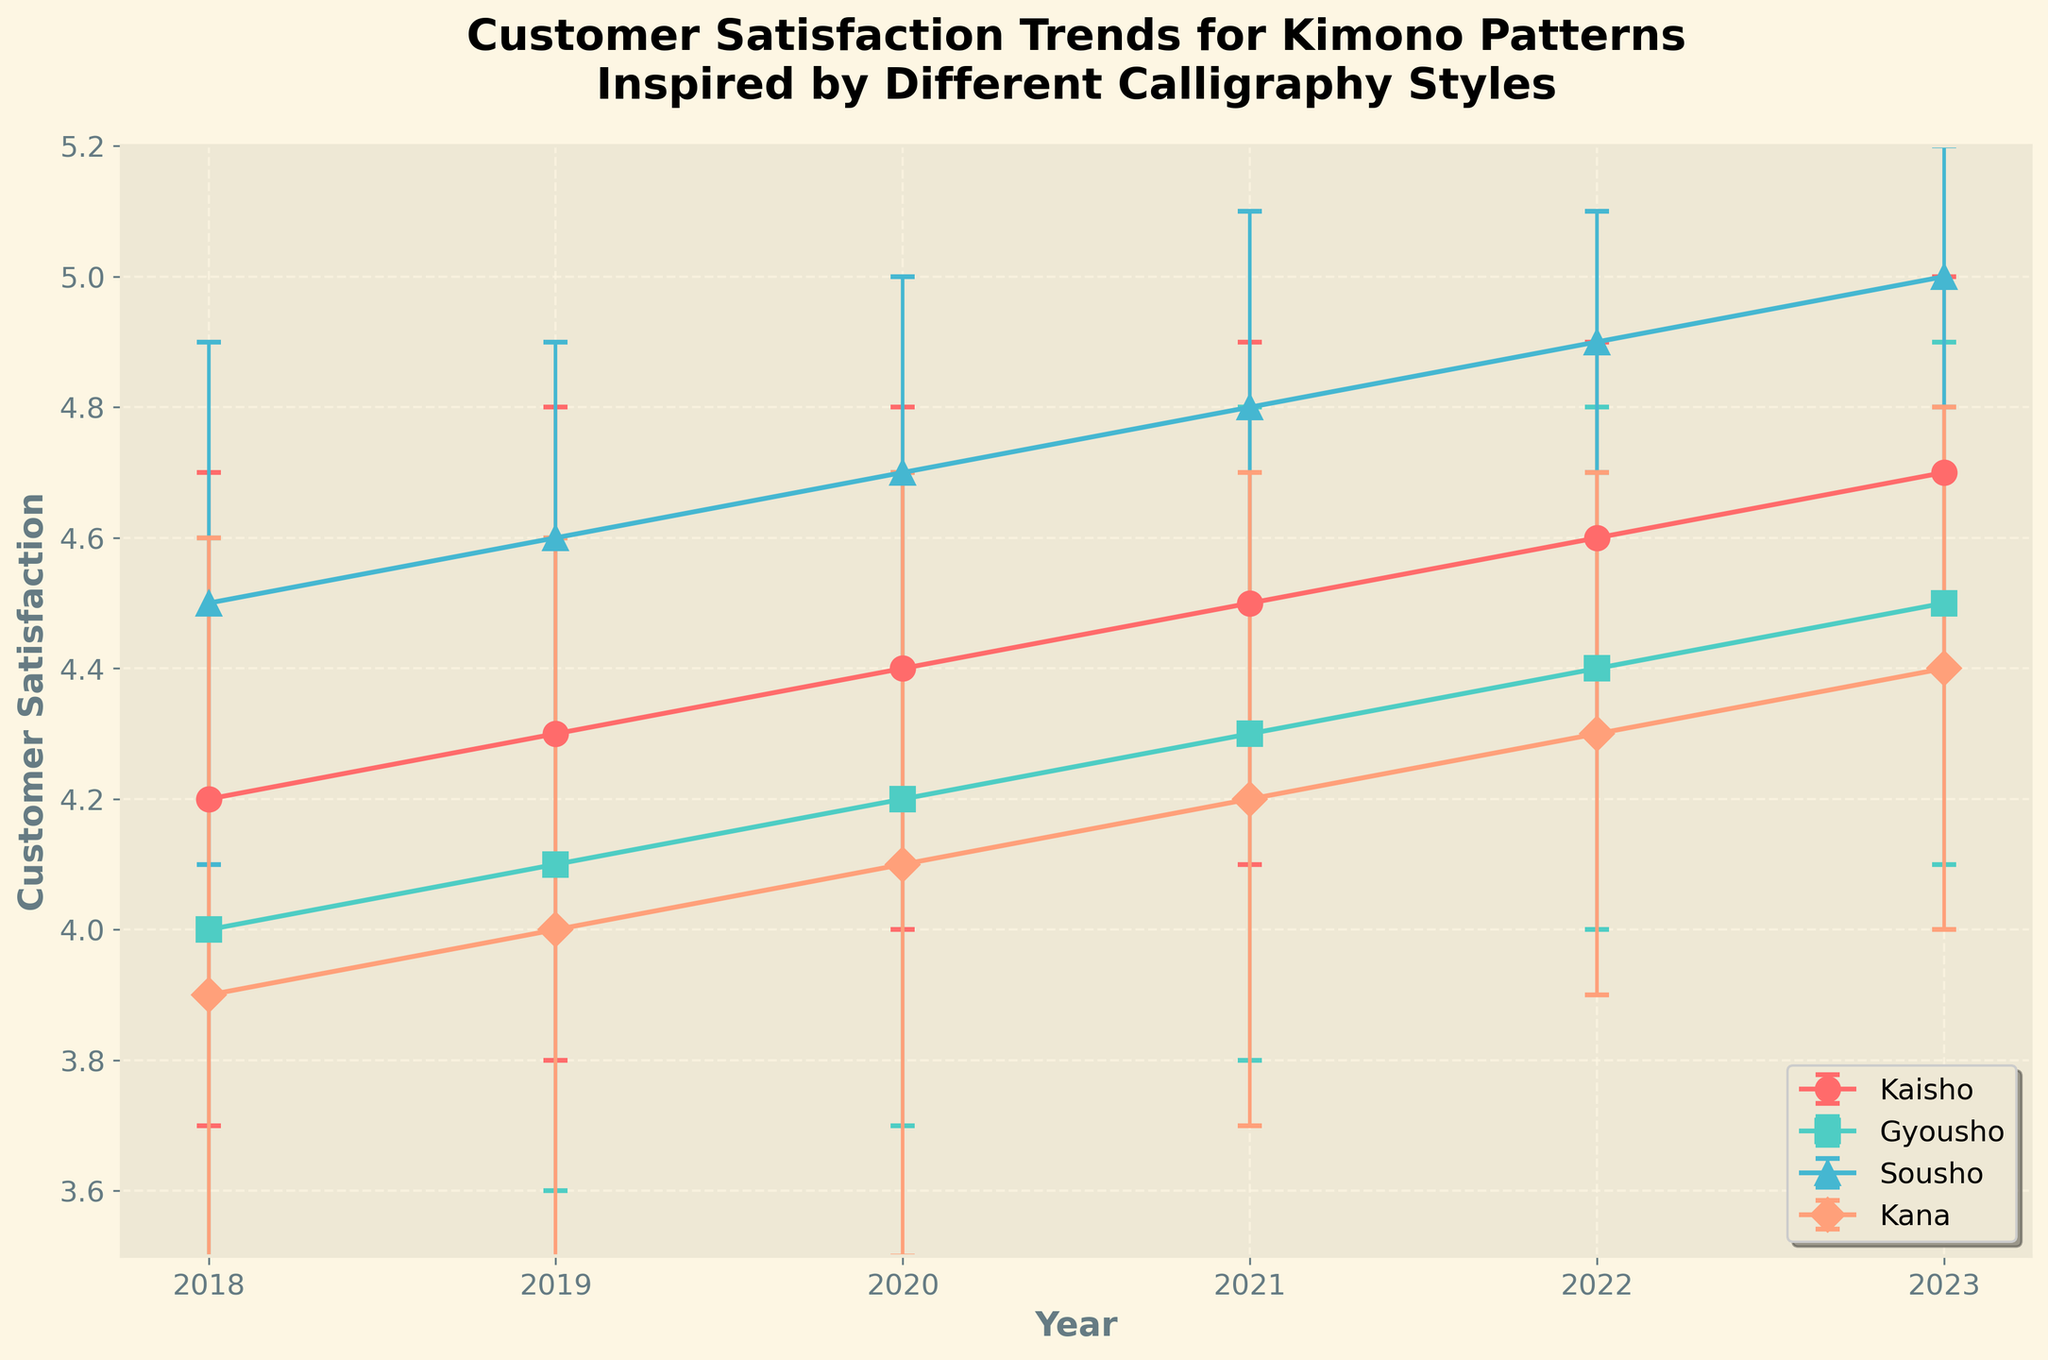What is the title of the plot? The title is displayed at the top of the plot and summarizes its main purpose, which is to show customer satisfaction trends for kimono patterns inspired by different calligraphy styles.
Answer: Customer Satisfaction Trends for Kimono Patterns Inspired by Different Calligraphy Styles Which calligraphy style had the highest customer satisfaction in 2018? By observing the plot, look for the highest data point in 2018 and identify the corresponding calligraphy style.
Answer: Sousho What is the trend of customer satisfaction for the Kana style from 2018 to 2023? Follow the line corresponding to the Kana style and observe the pattern of customer satisfaction over the years. Note if it increases, decreases, or remains constant.
Answer: Increasing How does the customer satisfaction for Gyousho in 2021 compare to Kaisho in the same year? Locate the points for both Gyousho and Kaisho in 2021 and compare their heights to determine which is higher.
Answer: Gyousho has lower satisfaction than Kaisho Which year had the smallest error bars for customer satisfaction across all styles? Error bars show the standard deviation. Look for the year where the error bars are shortest across all styles.
Answer: 2023 What is the difference in customer satisfaction between Sousho and Kana in 2023? Find the points for Sousho and Kana in 2023, then subtract the satisfaction level of Kana from that of Sousho.
Answer: 0.6 List all calligraphy styles that have shown a consistently increasing trend from 2018 to 2023. Follow the lines for each calligraphy style from 2018 to 2023 and determine which lines show a consistent increase.
Answer: All styles (Kaisho, Gyousho, Sousho, Kana) Compare the standard deviation for Kaisho and Sousho in 2020. Which one has a higher standard deviation? Check the error bars for Kaisho and Sousho in 2020; the longer error bar indicates a higher standard deviation.
Answer: Kaisho Which calligraphy style showed the smallest change in customer satisfaction between 2019 and 2022? Calculate the change in customer satisfaction for each style from 2019 to 2022 and find the style with the smallest difference.
Answer: Kana 